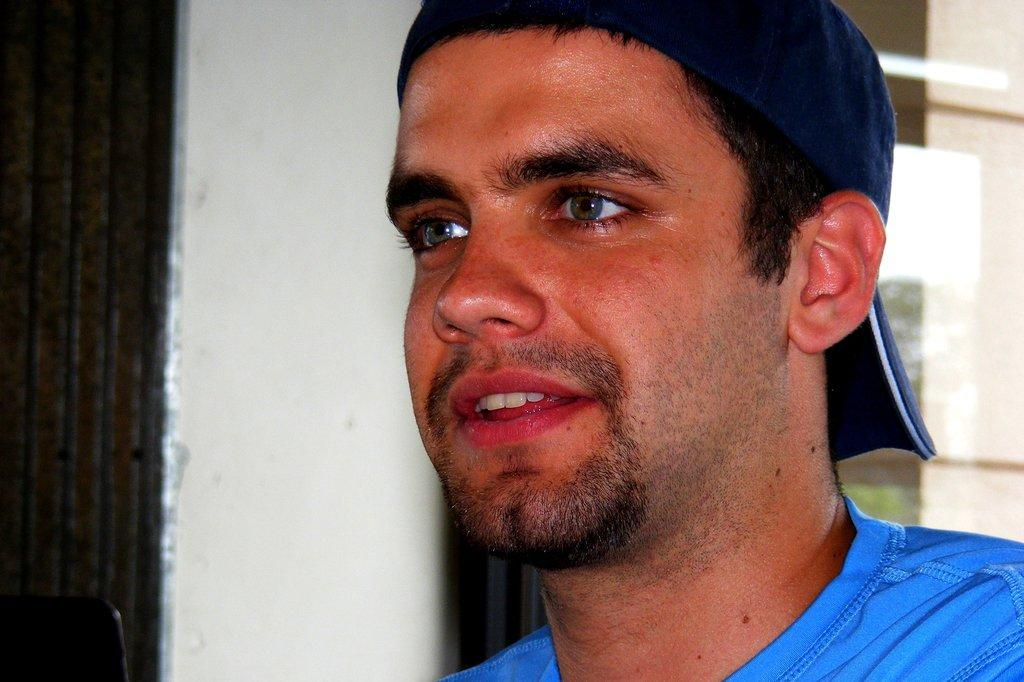Who is present in the image? There is a person in the image. What is the person wearing on their upper body? The person is wearing a blue T-shirt. What type of headwear is the person wearing? The person is wearing a cap. What can be seen in the background of the image? There is a wall in the background of the image. What piece of furniture is located in the left bottom of the image? There is a chair in the left bottom of the image. How many balls can be seen in the person's pocket in the image? There is no ball or pocket visible in the image. What type of step is the person taking in the image? There is no indication of the person taking a step in the image; they are standing still. 